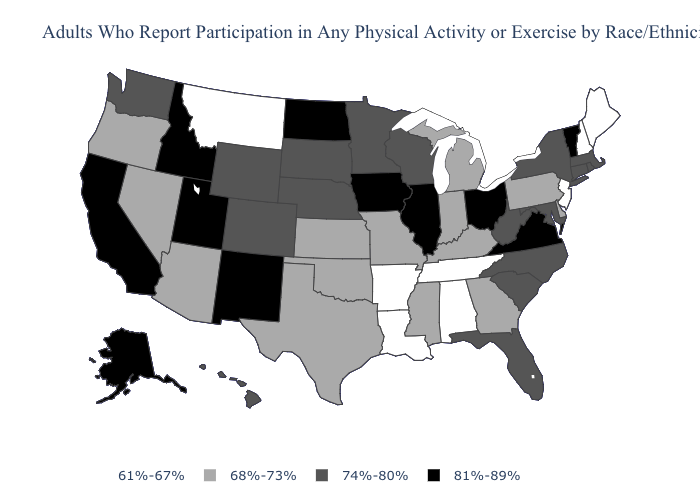What is the value of Arkansas?
Concise answer only. 61%-67%. Name the states that have a value in the range 81%-89%?
Keep it brief. Alaska, California, Idaho, Illinois, Iowa, New Mexico, North Dakota, Ohio, Utah, Vermont, Virginia. Which states hav the highest value in the Northeast?
Quick response, please. Vermont. Which states hav the highest value in the Northeast?
Answer briefly. Vermont. Name the states that have a value in the range 74%-80%?
Keep it brief. Colorado, Connecticut, Florida, Hawaii, Maryland, Massachusetts, Minnesota, Nebraska, New York, North Carolina, Rhode Island, South Carolina, South Dakota, Washington, West Virginia, Wisconsin, Wyoming. Among the states that border Kansas , does Colorado have the highest value?
Give a very brief answer. Yes. What is the lowest value in the West?
Short answer required. 61%-67%. Which states hav the highest value in the South?
Write a very short answer. Virginia. What is the value of New Hampshire?
Be succinct. 61%-67%. What is the lowest value in the USA?
Answer briefly. 61%-67%. Does the first symbol in the legend represent the smallest category?
Short answer required. Yes. Does Vermont have a lower value than Colorado?
Quick response, please. No. What is the value of South Dakota?
Give a very brief answer. 74%-80%. Does the map have missing data?
Give a very brief answer. No. Which states hav the highest value in the South?
Give a very brief answer. Virginia. 